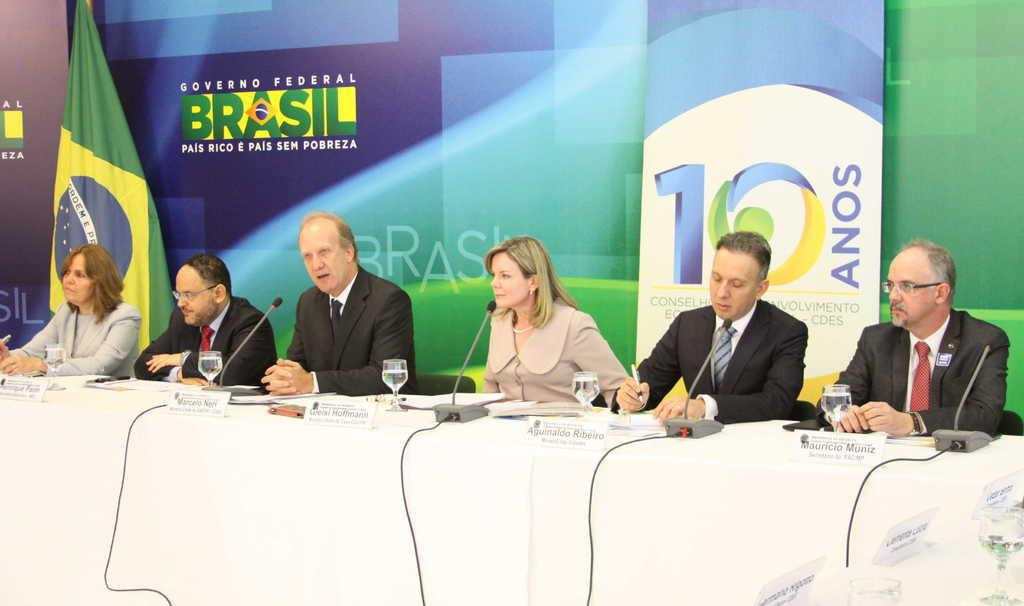How many people are in the image? There is a group of persons in the image. What are the persons in the image doing? The persons are sitting at a table. What objects can be seen on the table? There are mics, glasses, and papers on the table. What can be seen in the background of the image? There is a poster and a flag in the background. What type of tomatoes can be seen on the table in the image? There are no tomatoes present on the table in the image. What type of food is being served at the table in the image? The image does not show any food being served; it only shows mics, glasses, and papers on the table. 